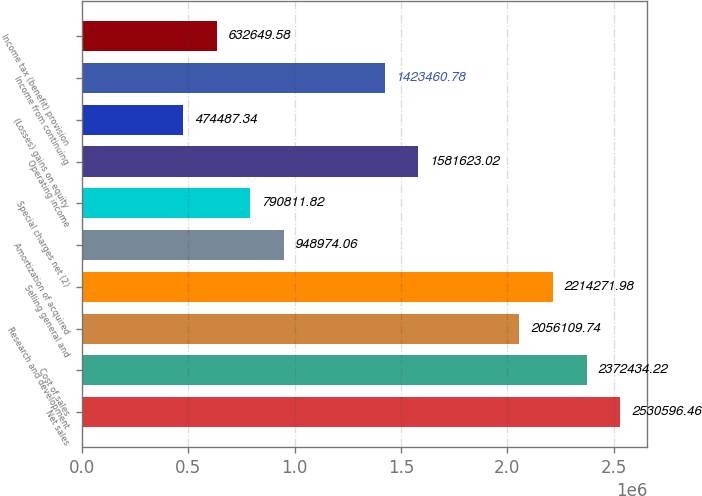<chart> <loc_0><loc_0><loc_500><loc_500><bar_chart><fcel>Net sales<fcel>Cost of sales<fcel>Research and development<fcel>Selling general and<fcel>Amortization of acquired<fcel>Special charges net (2)<fcel>Operating income<fcel>(Losses) gains on equity<fcel>Income from continuing<fcel>Income tax (benefit) provision<nl><fcel>2.5306e+06<fcel>2.37243e+06<fcel>2.05611e+06<fcel>2.21427e+06<fcel>948974<fcel>790812<fcel>1.58162e+06<fcel>474487<fcel>1.42346e+06<fcel>632650<nl></chart> 